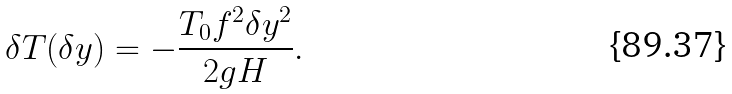Convert formula to latex. <formula><loc_0><loc_0><loc_500><loc_500>\delta T ( \delta y ) = - \frac { T _ { 0 } f ^ { 2 } \delta y ^ { 2 } } { 2 g H } .</formula> 